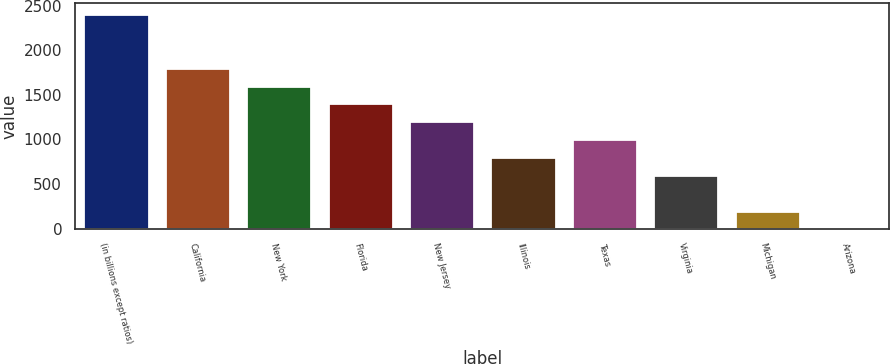Convert chart to OTSL. <chart><loc_0><loc_0><loc_500><loc_500><bar_chart><fcel>(in billions except ratios)<fcel>California<fcel>New York<fcel>Florida<fcel>New Jersey<fcel>Illinois<fcel>Texas<fcel>Virginia<fcel>Michigan<fcel>Arizona<nl><fcel>2405.76<fcel>1804.62<fcel>1604.24<fcel>1403.86<fcel>1203.48<fcel>802.72<fcel>1003.1<fcel>602.34<fcel>201.58<fcel>1.2<nl></chart> 